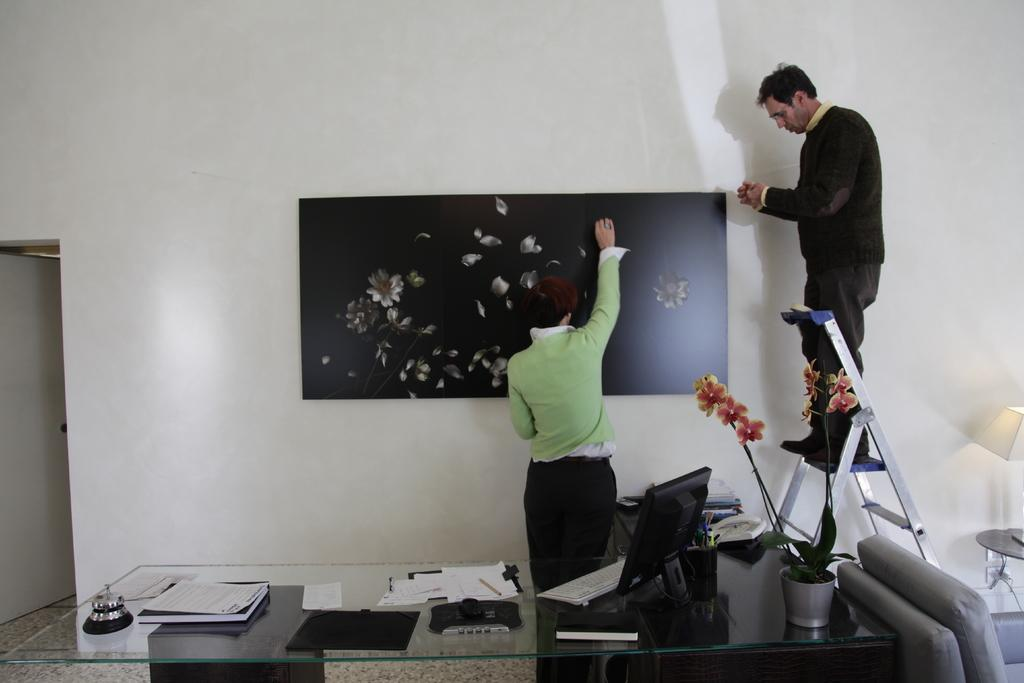What is the primary subject of the image? There is a woman standing in the image. What is the man in the image doing? The man is standing on a ladder in the image. What is on the table in the image? There is a monitor, a keyboard, papers, a pad, a pen, and a bell ringer on the table. What type of destruction is happening in the image? There is no destruction present in the image. How many people are in the crowd in the image? There is no crowd present in the image. 